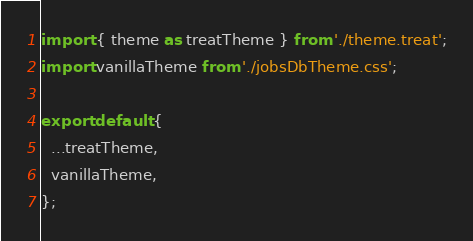<code> <loc_0><loc_0><loc_500><loc_500><_TypeScript_>import { theme as treatTheme } from './theme.treat';
import vanillaTheme from './jobsDbTheme.css';

export default {
  ...treatTheme,
  vanillaTheme,
};
</code> 